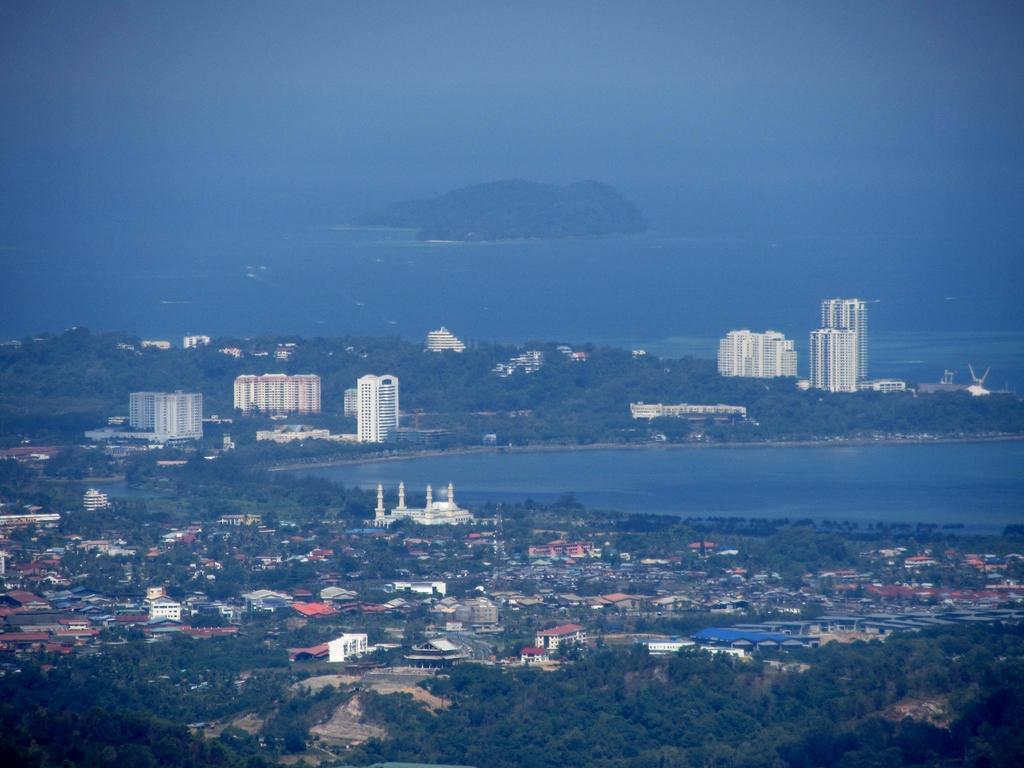Describe this image in one or two sentences. In this picture we can see buildings, trees, water and in the background we can see the sky. 